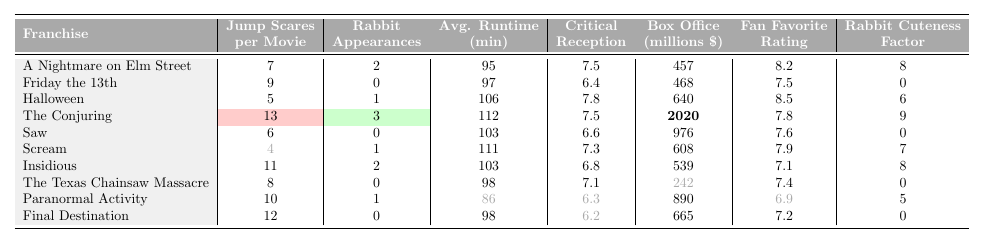What horror franchise has the highest frequency of jump scares per movie? The franchise with the highest frequency of jump scares per movie is The Conjuring, which has 13 jump scares.
Answer: The Conjuring How many rabbit appearances are there in the Halloween franchise? The Halloween franchise has 1 rabbit appearance, as shown in the table.
Answer: 1 Which franchise has the lowest critical reception score? The franchise with the lowest critical reception score is Final Destination, with a score of 6.2.
Answer: Final Destination What is the average number of jump scares across all franchises? To find the average number of jump scares, sum the jump scare counts (7 + 9 + 5 + 13 + 6 + 4 + 11 + 8 + 10 + 12 =  85) and divide by the number of franchises (10), giving an average of 8.5.
Answer: 8.5 Which franchise has the most rabbit appearances and what is the cuteness factor associated with it? The franchise with the most rabbit appearances is The Conjuring, which has 3 rabbit appearances and a rabbit cuteness factor of 9.
Answer: The Conjuring, 9 Is there a franchise with no rabbit appearances, and if so, which one? Yes, there are several franchises with no rabbit appearances, including Friday the 13th, Saw, The Texas Chainsaw Massacre, and Final Destination.
Answer: Yes, several franchises What is the total box office revenue of the franchises that have at least one rabbit appearance? The franchises with rabbit appearances are A Nightmare on Elm Street (457), Halloween (640), The Conjuring (2020), Insidious (539), and Paranormal Activity (890). Adding these gives a total of 457 + 640 + 2020 + 539 + 890 = 4646 million.
Answer: 4646 million How does the fan-favorite rating compare between franchises with and without rabbit appearances? For franchises with rabbit appearances (average rating = 7.42) versus those without (average rating = 7.22), we calculate both groups' average ratings. Therefore, franchises with rabbit appearances have a higher average fan-favorite rating.
Answer: Higher for franchises with rabbit appearances Which franchise has the longest average movie runtime and how many jump scares does it have? The Conjuring has the longest average movie runtime at 112 minutes, and it has 13 jump scares.
Answer: The Conjuring, 13 jump scares What is the difference in jump scares per movie between the franchise with the highest and lowest jump scares? The highest is The Conjuring with 13 jump scares, and the lowest is Scream with 4 jump scares. The difference is 13 - 4 = 9 jump scares.
Answer: 9 jump scares Which franchise has more average running time, Paranormal Activity or Saw, and by how much? Paranormal Activity has an average runtime of 86 minutes, while Saw has 103 minutes. The difference is 103 - 86 = 17 minutes, making Saw longer.
Answer: Saw, by 17 minutes 